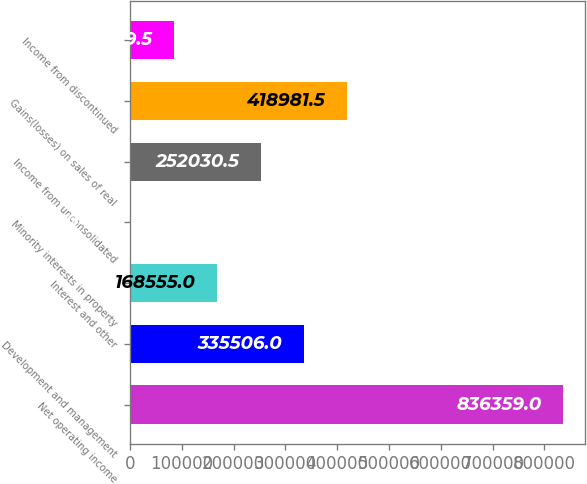Convert chart. <chart><loc_0><loc_0><loc_500><loc_500><bar_chart><fcel>Net operating income<fcel>Development and management<fcel>Interest and other<fcel>Minority interests in property<fcel>Income from unconsolidated<fcel>Gains(losses) on sales of real<fcel>Income from discontinued<nl><fcel>836359<fcel>335506<fcel>168555<fcel>1604<fcel>252030<fcel>418982<fcel>85079.5<nl></chart> 